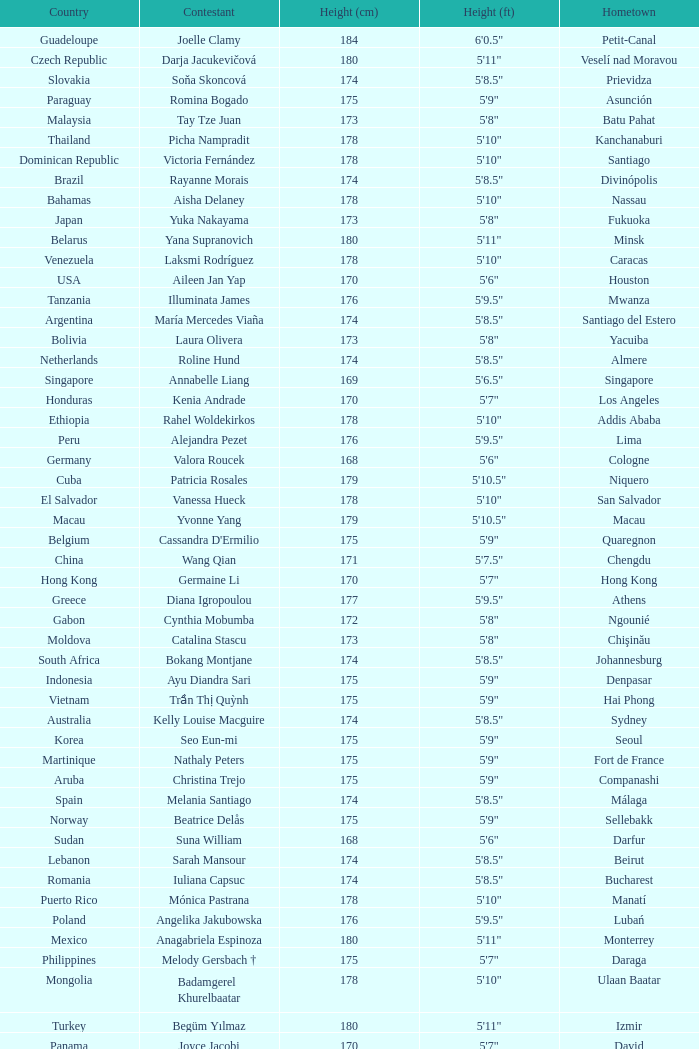What is Cynthia Mobumba's height? 5'8". 